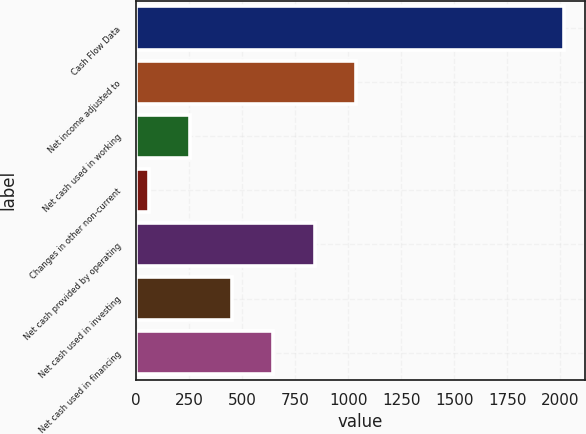Convert chart to OTSL. <chart><loc_0><loc_0><loc_500><loc_500><bar_chart><fcel>Cash Flow Data<fcel>Net income adjusted to<fcel>Net cash used in working<fcel>Changes in other non-current<fcel>Net cash provided by operating<fcel>Net cash used in investing<fcel>Net cash used in financing<nl><fcel>2015<fcel>1037.7<fcel>255.86<fcel>60.4<fcel>842.24<fcel>451.32<fcel>646.78<nl></chart> 